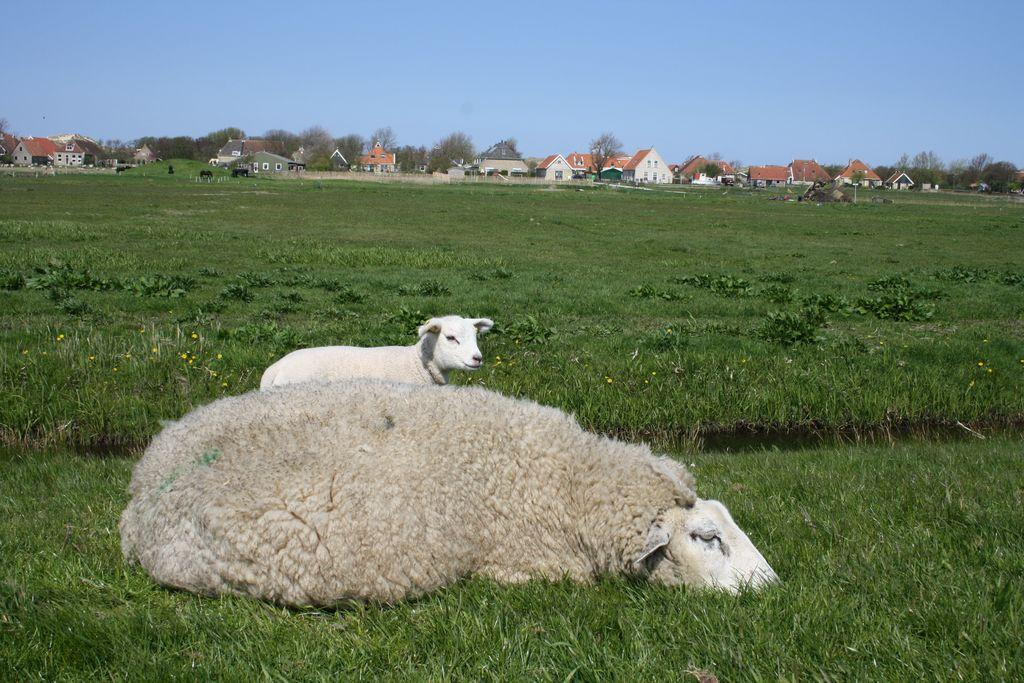What type of animals can be seen in the image? There is a sheep and a lamb in the image. What is visible in the background of the image? There are buildings and trees in the background of the image. What is visible at the top of the image? The sky is visible at the top of the image. What type of glass is being used to tell the story in the image? There is no glass or story present in the image; it features a sheep and a lamb with buildings, trees, and sky in the background. 